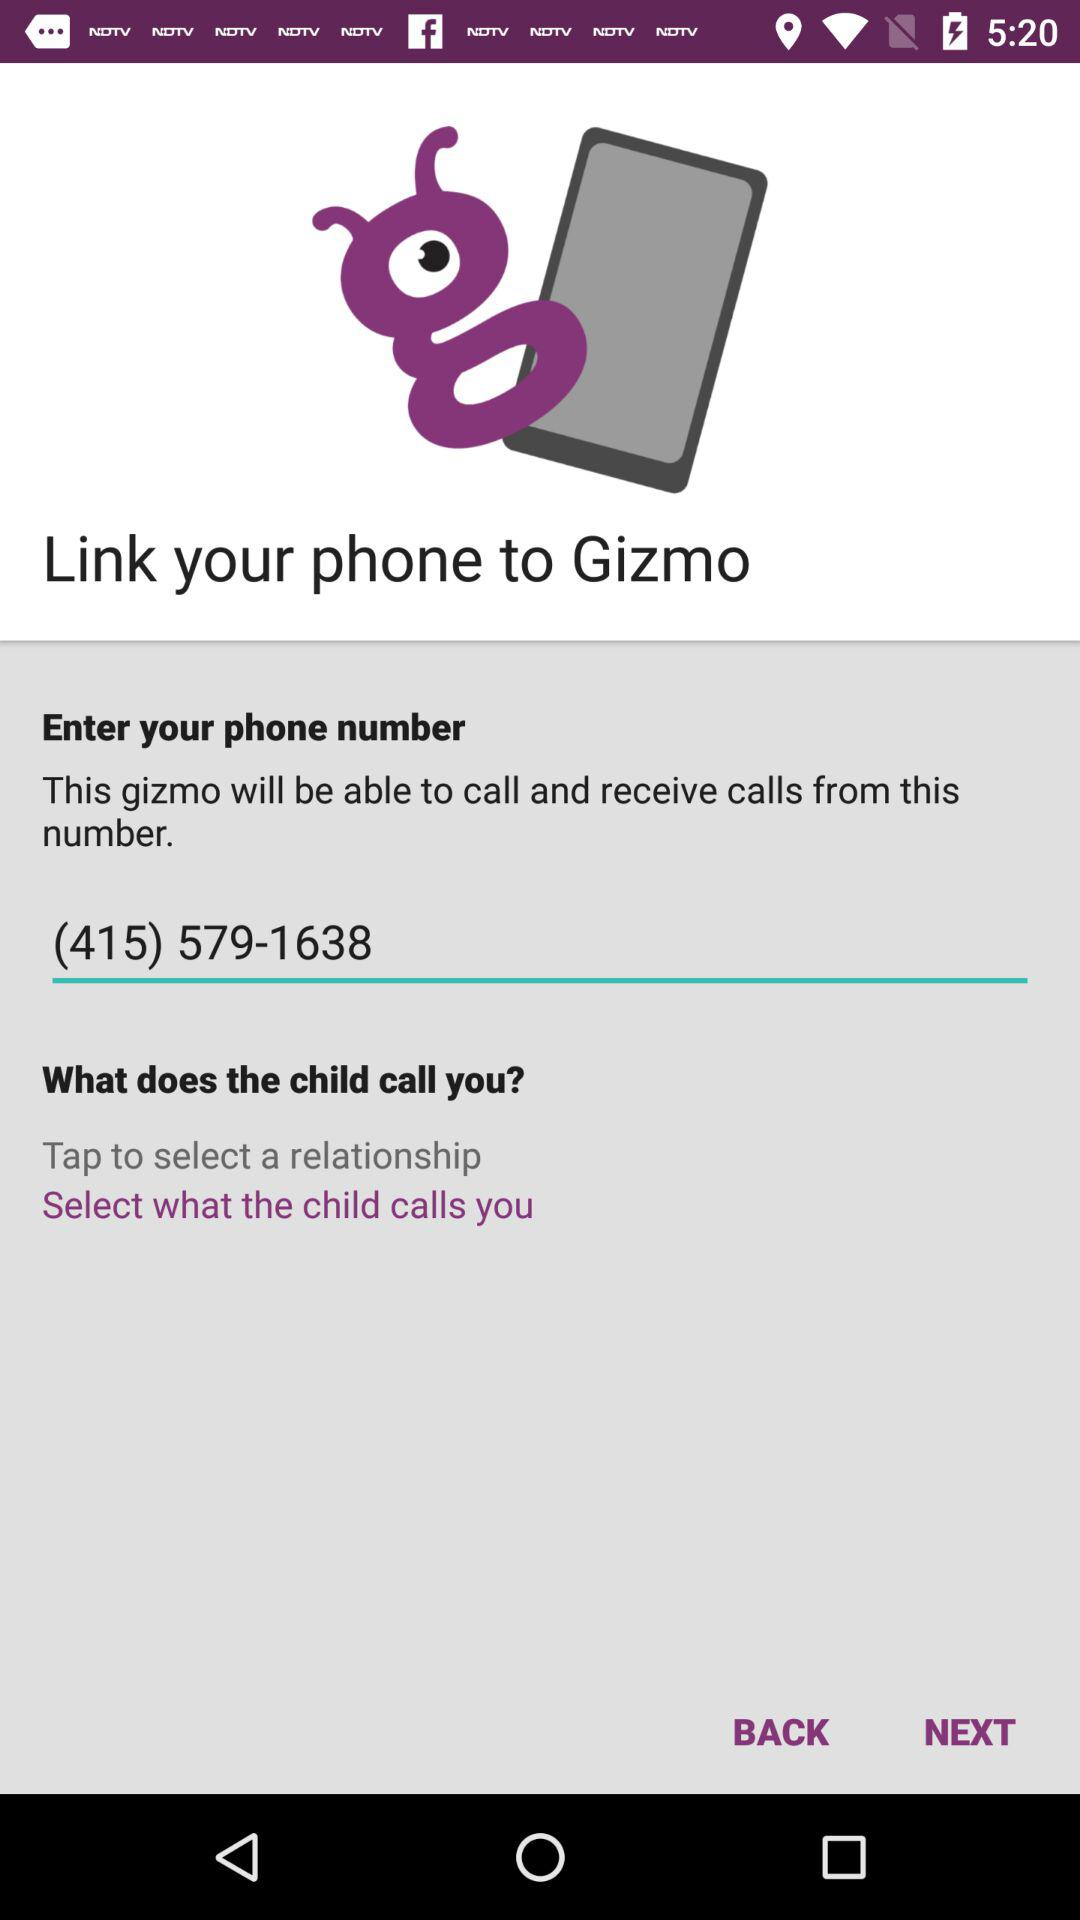What is the name of the application? The name of the application is "Gizmo". 